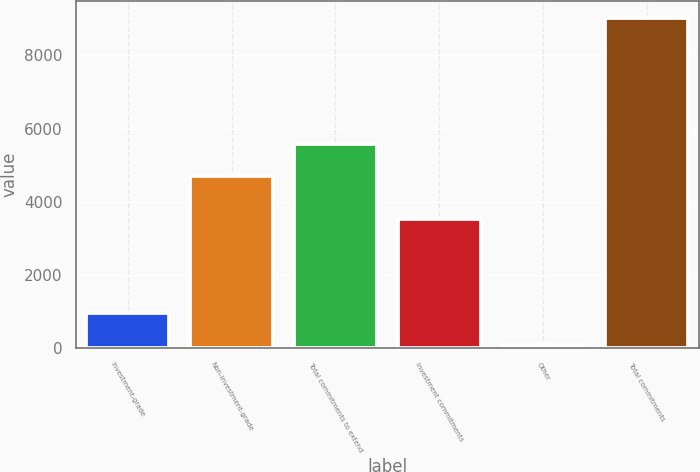Convert chart to OTSL. <chart><loc_0><loc_0><loc_500><loc_500><bar_chart><fcel>Investment-grade<fcel>Non-investment-grade<fcel>Total commitments to extend<fcel>Investment commitments<fcel>Other<fcel>Total commitments<nl><fcel>964.6<fcel>4693<fcel>5588.6<fcel>3529<fcel>69<fcel>9025<nl></chart> 